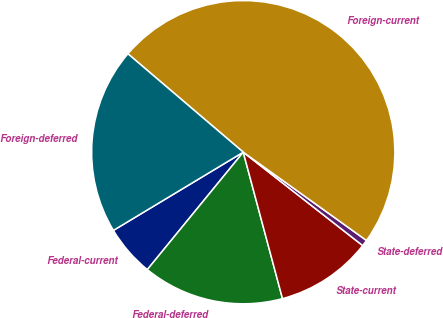Convert chart to OTSL. <chart><loc_0><loc_0><loc_500><loc_500><pie_chart><fcel>Federal-current<fcel>Federal-deferred<fcel>State-current<fcel>State-deferred<fcel>Foreign-current<fcel>Foreign-deferred<nl><fcel>5.47%<fcel>15.07%<fcel>10.27%<fcel>0.67%<fcel>48.66%<fcel>19.87%<nl></chart> 